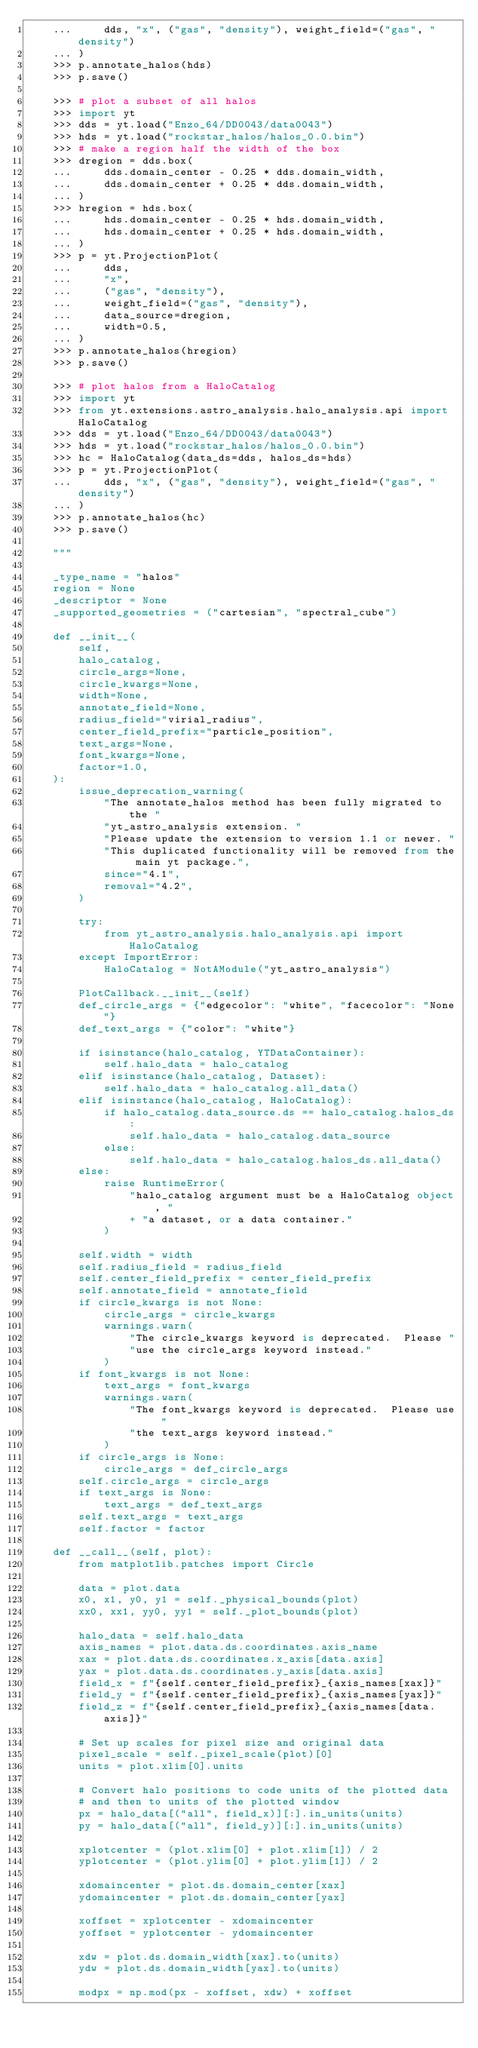Convert code to text. <code><loc_0><loc_0><loc_500><loc_500><_Python_>    ...     dds, "x", ("gas", "density"), weight_field=("gas", "density")
    ... )
    >>> p.annotate_halos(hds)
    >>> p.save()

    >>> # plot a subset of all halos
    >>> import yt
    >>> dds = yt.load("Enzo_64/DD0043/data0043")
    >>> hds = yt.load("rockstar_halos/halos_0.0.bin")
    >>> # make a region half the width of the box
    >>> dregion = dds.box(
    ...     dds.domain_center - 0.25 * dds.domain_width,
    ...     dds.domain_center + 0.25 * dds.domain_width,
    ... )
    >>> hregion = hds.box(
    ...     hds.domain_center - 0.25 * hds.domain_width,
    ...     hds.domain_center + 0.25 * hds.domain_width,
    ... )
    >>> p = yt.ProjectionPlot(
    ...     dds,
    ...     "x",
    ...     ("gas", "density"),
    ...     weight_field=("gas", "density"),
    ...     data_source=dregion,
    ...     width=0.5,
    ... )
    >>> p.annotate_halos(hregion)
    >>> p.save()

    >>> # plot halos from a HaloCatalog
    >>> import yt
    >>> from yt.extensions.astro_analysis.halo_analysis.api import HaloCatalog
    >>> dds = yt.load("Enzo_64/DD0043/data0043")
    >>> hds = yt.load("rockstar_halos/halos_0.0.bin")
    >>> hc = HaloCatalog(data_ds=dds, halos_ds=hds)
    >>> p = yt.ProjectionPlot(
    ...     dds, "x", ("gas", "density"), weight_field=("gas", "density")
    ... )
    >>> p.annotate_halos(hc)
    >>> p.save()

    """

    _type_name = "halos"
    region = None
    _descriptor = None
    _supported_geometries = ("cartesian", "spectral_cube")

    def __init__(
        self,
        halo_catalog,
        circle_args=None,
        circle_kwargs=None,
        width=None,
        annotate_field=None,
        radius_field="virial_radius",
        center_field_prefix="particle_position",
        text_args=None,
        font_kwargs=None,
        factor=1.0,
    ):
        issue_deprecation_warning(
            "The annotate_halos method has been fully migrated to the "
            "yt_astro_analysis extension. "
            "Please update the extension to version 1.1 or newer. "
            "This duplicated functionality will be removed from the main yt package.",
            since="4.1",
            removal="4.2",
        )

        try:
            from yt_astro_analysis.halo_analysis.api import HaloCatalog
        except ImportError:
            HaloCatalog = NotAModule("yt_astro_analysis")

        PlotCallback.__init__(self)
        def_circle_args = {"edgecolor": "white", "facecolor": "None"}
        def_text_args = {"color": "white"}

        if isinstance(halo_catalog, YTDataContainer):
            self.halo_data = halo_catalog
        elif isinstance(halo_catalog, Dataset):
            self.halo_data = halo_catalog.all_data()
        elif isinstance(halo_catalog, HaloCatalog):
            if halo_catalog.data_source.ds == halo_catalog.halos_ds:
                self.halo_data = halo_catalog.data_source
            else:
                self.halo_data = halo_catalog.halos_ds.all_data()
        else:
            raise RuntimeError(
                "halo_catalog argument must be a HaloCatalog object, "
                + "a dataset, or a data container."
            )

        self.width = width
        self.radius_field = radius_field
        self.center_field_prefix = center_field_prefix
        self.annotate_field = annotate_field
        if circle_kwargs is not None:
            circle_args = circle_kwargs
            warnings.warn(
                "The circle_kwargs keyword is deprecated.  Please "
                "use the circle_args keyword instead."
            )
        if font_kwargs is not None:
            text_args = font_kwargs
            warnings.warn(
                "The font_kwargs keyword is deprecated.  Please use "
                "the text_args keyword instead."
            )
        if circle_args is None:
            circle_args = def_circle_args
        self.circle_args = circle_args
        if text_args is None:
            text_args = def_text_args
        self.text_args = text_args
        self.factor = factor

    def __call__(self, plot):
        from matplotlib.patches import Circle

        data = plot.data
        x0, x1, y0, y1 = self._physical_bounds(plot)
        xx0, xx1, yy0, yy1 = self._plot_bounds(plot)

        halo_data = self.halo_data
        axis_names = plot.data.ds.coordinates.axis_name
        xax = plot.data.ds.coordinates.x_axis[data.axis]
        yax = plot.data.ds.coordinates.y_axis[data.axis]
        field_x = f"{self.center_field_prefix}_{axis_names[xax]}"
        field_y = f"{self.center_field_prefix}_{axis_names[yax]}"
        field_z = f"{self.center_field_prefix}_{axis_names[data.axis]}"

        # Set up scales for pixel size and original data
        pixel_scale = self._pixel_scale(plot)[0]
        units = plot.xlim[0].units

        # Convert halo positions to code units of the plotted data
        # and then to units of the plotted window
        px = halo_data[("all", field_x)][:].in_units(units)
        py = halo_data[("all", field_y)][:].in_units(units)

        xplotcenter = (plot.xlim[0] + plot.xlim[1]) / 2
        yplotcenter = (plot.ylim[0] + plot.ylim[1]) / 2

        xdomaincenter = plot.ds.domain_center[xax]
        ydomaincenter = plot.ds.domain_center[yax]

        xoffset = xplotcenter - xdomaincenter
        yoffset = yplotcenter - ydomaincenter

        xdw = plot.ds.domain_width[xax].to(units)
        ydw = plot.ds.domain_width[yax].to(units)

        modpx = np.mod(px - xoffset, xdw) + xoffset</code> 